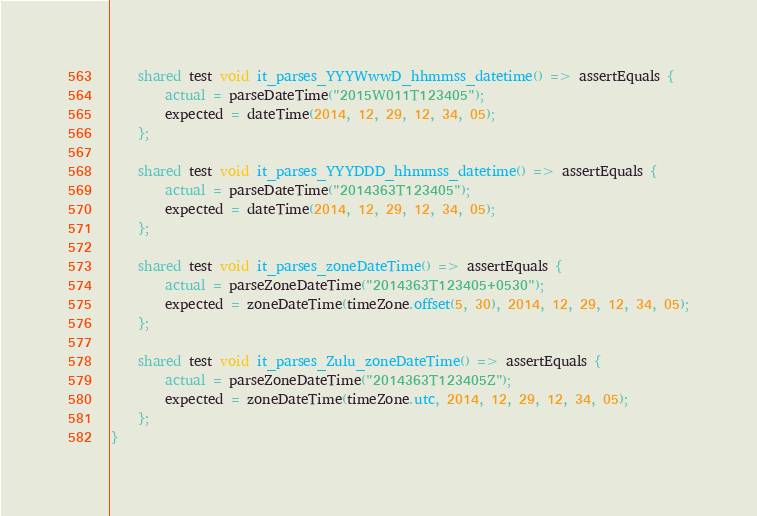Convert code to text. <code><loc_0><loc_0><loc_500><loc_500><_Ceylon_>    shared test void it_parses_YYYWwwD_hhmmss_datetime() => assertEquals {
        actual = parseDateTime("2015W011T123405");
        expected = dateTime(2014, 12, 29, 12, 34, 05);
    };
    
    shared test void it_parses_YYYDDD_hhmmss_datetime() => assertEquals {
        actual = parseDateTime("2014363T123405");
        expected = dateTime(2014, 12, 29, 12, 34, 05);
    };
    
    shared test void it_parses_zoneDateTime() => assertEquals {
        actual = parseZoneDateTime("2014363T123405+0530");
        expected = zoneDateTime(timeZone.offset(5, 30), 2014, 12, 29, 12, 34, 05);
    };
    
    shared test void it_parses_Zulu_zoneDateTime() => assertEquals {
        actual = parseZoneDateTime("2014363T123405Z");
        expected = zoneDateTime(timeZone.utc, 2014, 12, 29, 12, 34, 05);
    };
}

</code> 